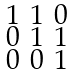<formula> <loc_0><loc_0><loc_500><loc_500>\begin{smallmatrix} 1 & 1 & 0 \\ 0 & 1 & 1 \\ 0 & 0 & 1 \end{smallmatrix}</formula> 